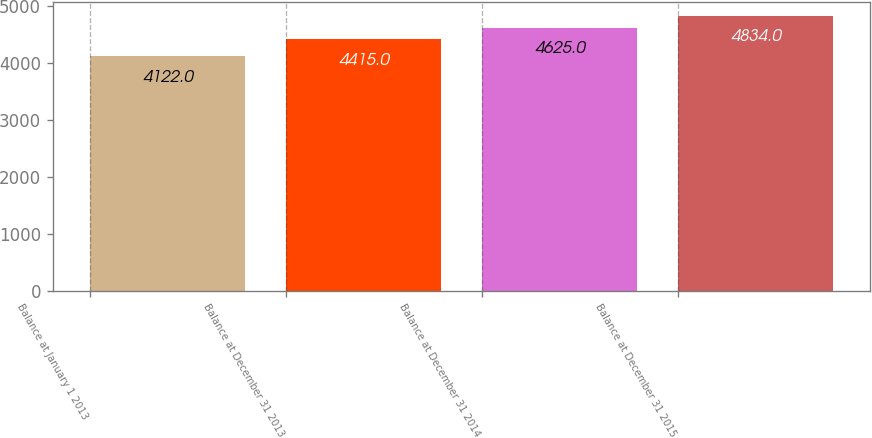Convert chart. <chart><loc_0><loc_0><loc_500><loc_500><bar_chart><fcel>Balance at January 1 2013<fcel>Balance at December 31 2013<fcel>Balance at December 31 2014<fcel>Balance at December 31 2015<nl><fcel>4122<fcel>4415<fcel>4625<fcel>4834<nl></chart> 